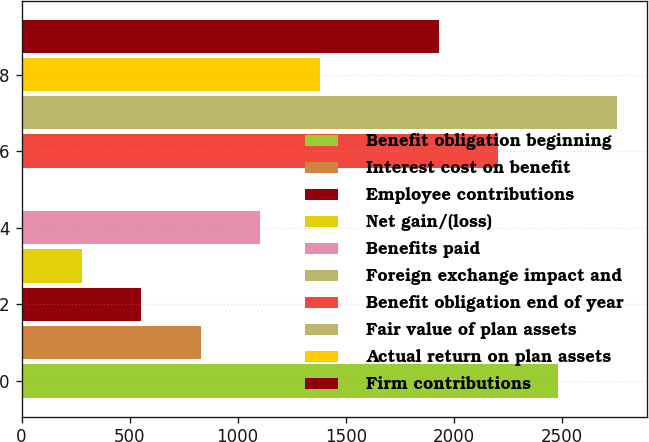Convert chart. <chart><loc_0><loc_0><loc_500><loc_500><bar_chart><fcel>Benefit obligation beginning<fcel>Interest cost on benefit<fcel>Employee contributions<fcel>Net gain/(loss)<fcel>Benefits paid<fcel>Foreign exchange impact and<fcel>Benefit obligation end of year<fcel>Fair value of plan assets<fcel>Actual return on plan assets<fcel>Firm contributions<nl><fcel>2481.6<fcel>829.2<fcel>553.8<fcel>278.4<fcel>1104.6<fcel>3<fcel>2206.2<fcel>2757<fcel>1380<fcel>1930.8<nl></chart> 